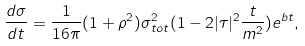<formula> <loc_0><loc_0><loc_500><loc_500>\frac { d \sigma } { d t } = \frac { 1 } { 1 6 \pi } ( 1 + \rho ^ { 2 } ) \sigma _ { t o t } ^ { 2 } ( 1 - 2 | \tau | ^ { 2 } \frac { t } { m ^ { 2 } } ) e ^ { b t } ,</formula> 